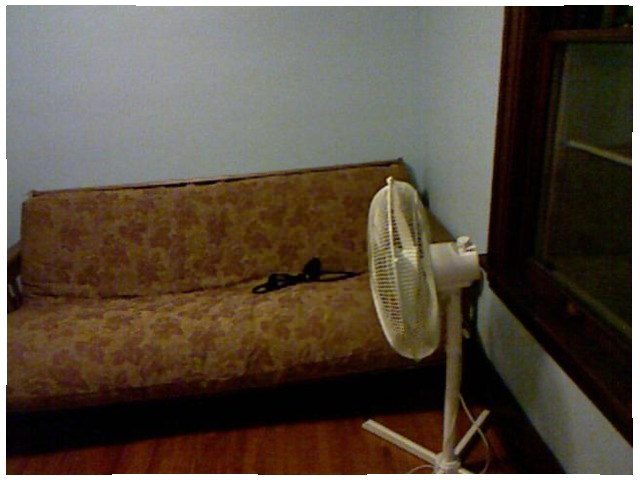<image>
Is the fan in front of the sofa? Yes. The fan is positioned in front of the sofa, appearing closer to the camera viewpoint. Where is the fan in relation to the couch? Is it in front of the couch? Yes. The fan is positioned in front of the couch, appearing closer to the camera viewpoint. Is the fan on the sofa? No. The fan is not positioned on the sofa. They may be near each other, but the fan is not supported by or resting on top of the sofa. Is the fan under the couch? No. The fan is not positioned under the couch. The vertical relationship between these objects is different. Is the sofa above the fan? No. The sofa is not positioned above the fan. The vertical arrangement shows a different relationship. 